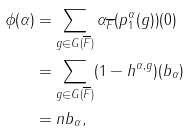<formula> <loc_0><loc_0><loc_500><loc_500>\phi ( \alpha ) & = \sum _ { g \in G ( \overline { F } ) } \alpha _ { \overline { F } } ( p _ { 1 } ^ { \alpha } ( g ) ) ( 0 ) \\ & = \sum _ { g \in G ( \overline { F } ) } ( 1 - h ^ { \alpha , g } ) ( b _ { \alpha } ) \\ & = n b _ { \alpha } ,</formula> 